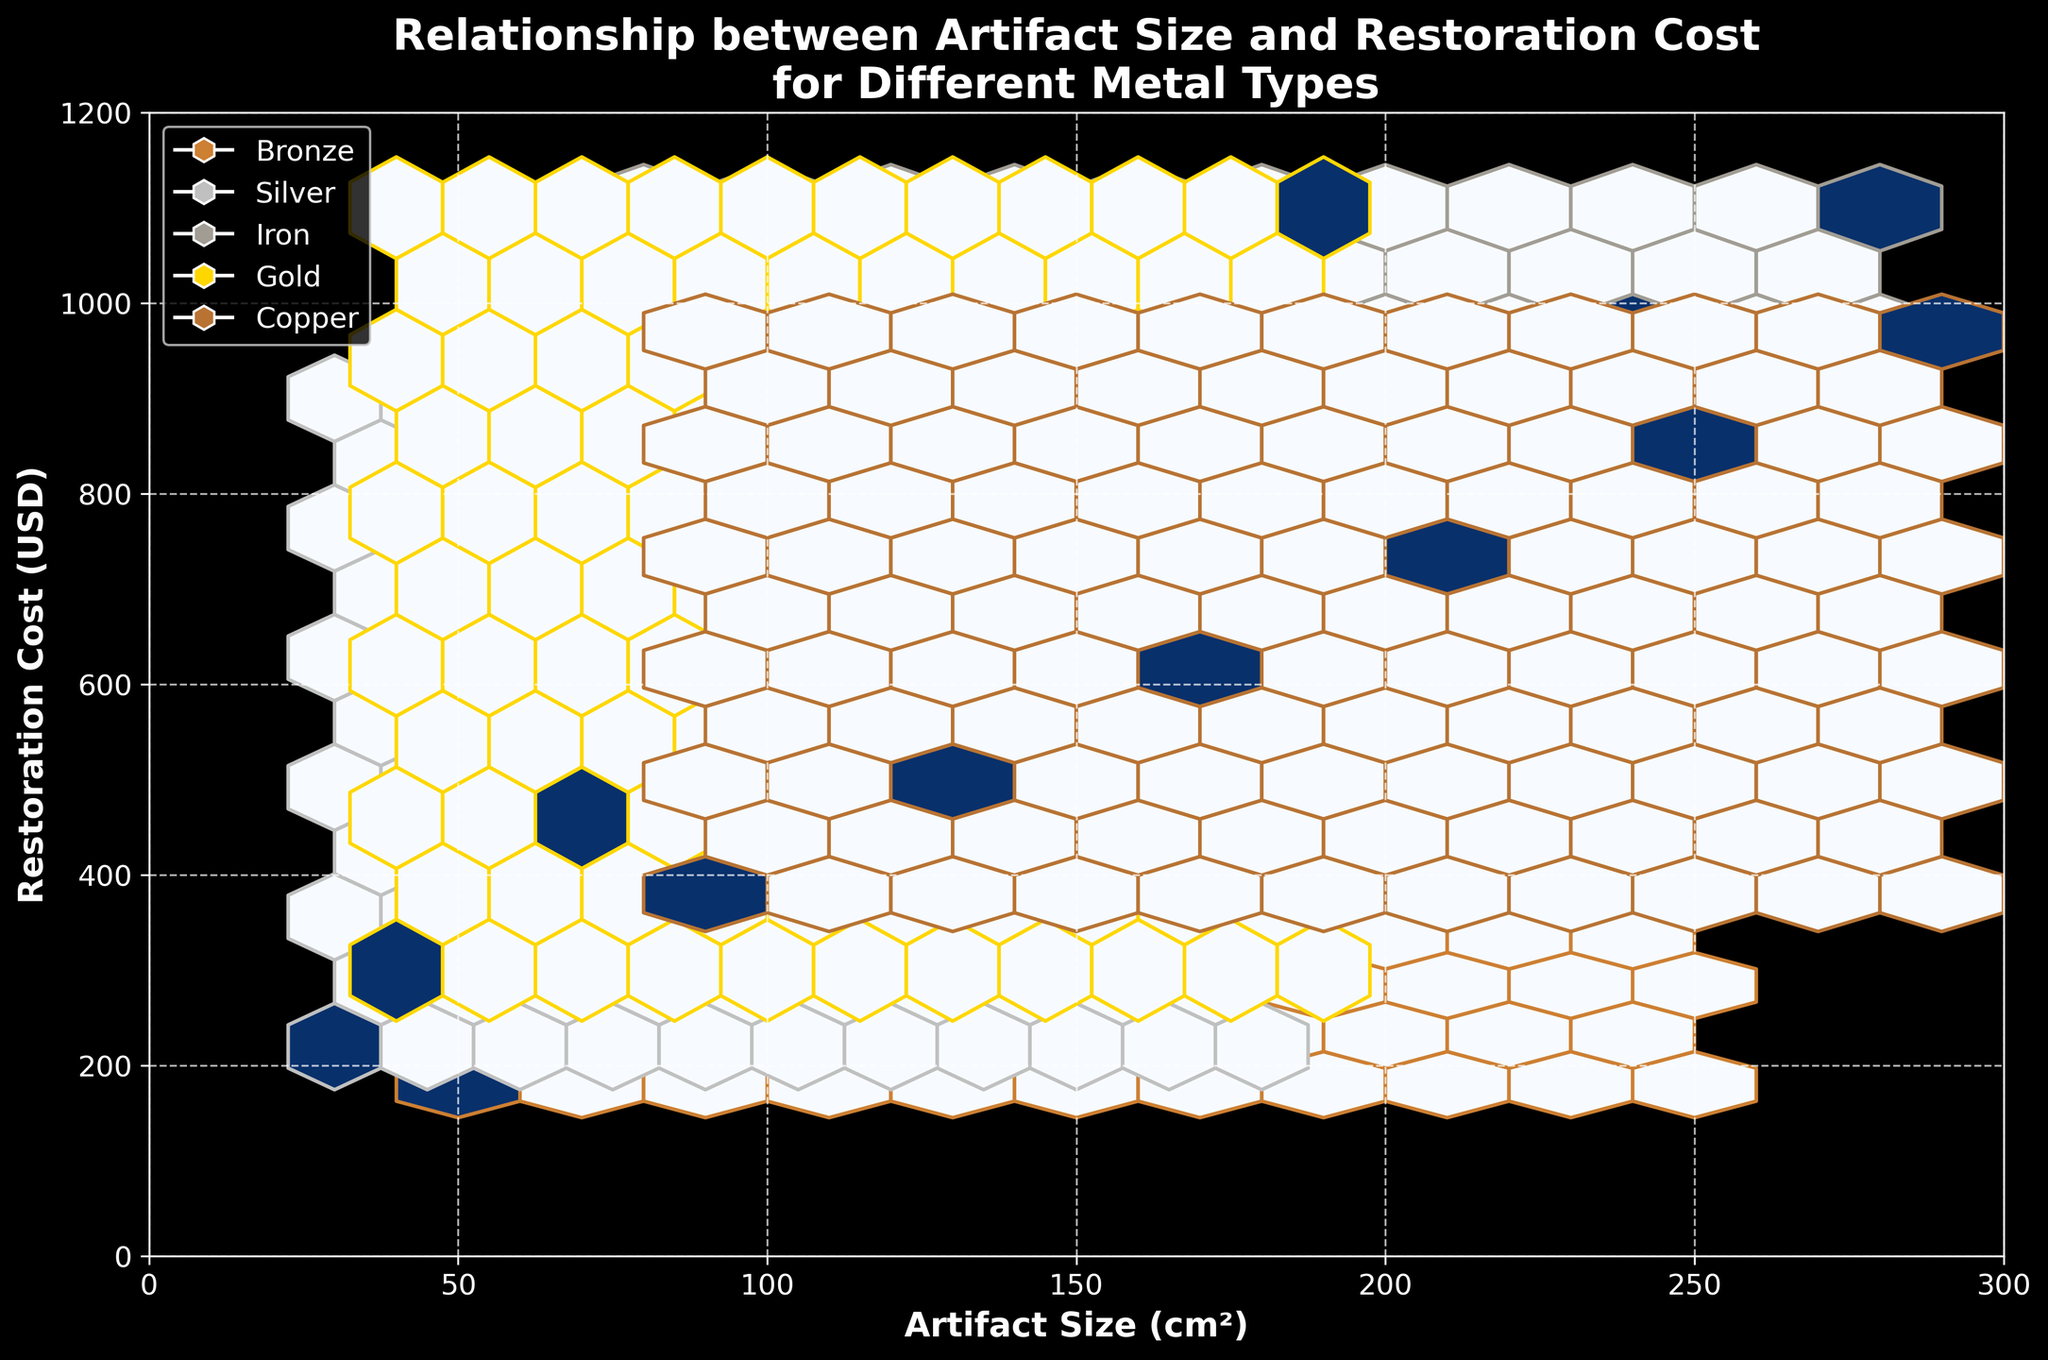What is the title of the plot? The title is located at the top of the plot and reads, "Relationship between Artifact Size and Restoration Cost for Different Metal Types".
Answer: Relationship between Artifact Size and Restoration Cost for Different Metal Types What does the x-axis represent? The x-axis label states "Artifact Size (cm²)", indicating that the horizontal axis represents the size of the artifacts in square centimeters.
Answer: Artifact Size (cm²) What does the y-axis represent? The y-axis label states "Restoration Cost (USD)", indicating the vertical axis represents the cost of restoring the artifacts in US dollars.
Answer: Restoration Cost (USD) Which metal type is represented by the color gold in the plot? The legend indicates that the gold color corresponds to artifacts made of "Gold".
Answer: Gold How many metal types are represented in the plot? The legend contains five different colored symbols, each representing a different metal type.
Answer: 5 Which metal type generally has the highest restoration costs for a given artifact size? By comparing the colors and their respective positions, it appears that "Gold" has the highest restoration costs for a given artifact size, as it is consistently above the other metal types.
Answer: Gold Are there any metal types where the restoration cost is more variable for a given artifact size? Observing the density of hexagons and spread on the y-axis, the restoration cost for "Silver" appears more variable, as the hexagons are less densely packed and spread further across the cost axis compared to other metals.
Answer: Silver For which artifact size range does Bronze have the most data points? The density and concentration of hexagons for Bronze indicate the majority of data points are within the 50 cm² to 200 cm² range.
Answer: 50 to 200 cm² How do artifact sizes between 150 and 200 cm² compare in restoration costs between Bronze and Iron? Focusing on the overlapping x-axis range (150-200 cm²), Bronze has lower restoration costs that range from $450 to $580 compared to Iron, which ranges from $720 to $850.
Answer: Bronze is less expensive What type of pattern can you observe for Silver artifacts between 60 and 90 cm² in terms of restoration cost? The trend for Silver artifacts shows that restoration costs increase linearly as the artifact size increases from 60 to 90 cm².
Answer: Linear increase 